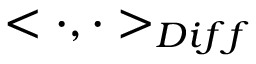<formula> <loc_0><loc_0><loc_500><loc_500>< \cdot , \cdot > _ { D i f f }</formula> 